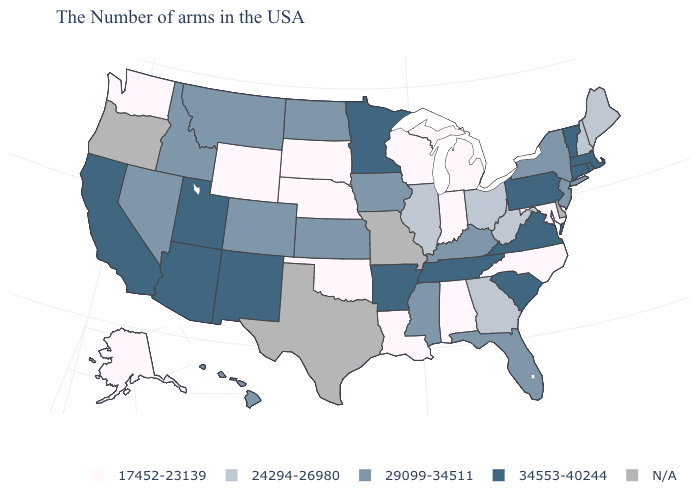Name the states that have a value in the range 29099-34511?
Write a very short answer. New York, New Jersey, Florida, Kentucky, Mississippi, Iowa, Kansas, North Dakota, Colorado, Montana, Idaho, Nevada, Hawaii. Is the legend a continuous bar?
Be succinct. No. Is the legend a continuous bar?
Concise answer only. No. What is the value of Massachusetts?
Keep it brief. 34553-40244. What is the value of Connecticut?
Keep it brief. 34553-40244. Name the states that have a value in the range 29099-34511?
Answer briefly. New York, New Jersey, Florida, Kentucky, Mississippi, Iowa, Kansas, North Dakota, Colorado, Montana, Idaho, Nevada, Hawaii. Does the map have missing data?
Keep it brief. Yes. What is the value of Connecticut?
Answer briefly. 34553-40244. What is the lowest value in states that border Kansas?
Quick response, please. 17452-23139. Name the states that have a value in the range 24294-26980?
Be succinct. Maine, New Hampshire, West Virginia, Ohio, Georgia, Illinois. Name the states that have a value in the range 24294-26980?
Concise answer only. Maine, New Hampshire, West Virginia, Ohio, Georgia, Illinois. Does North Dakota have the lowest value in the MidWest?
Answer briefly. No. 